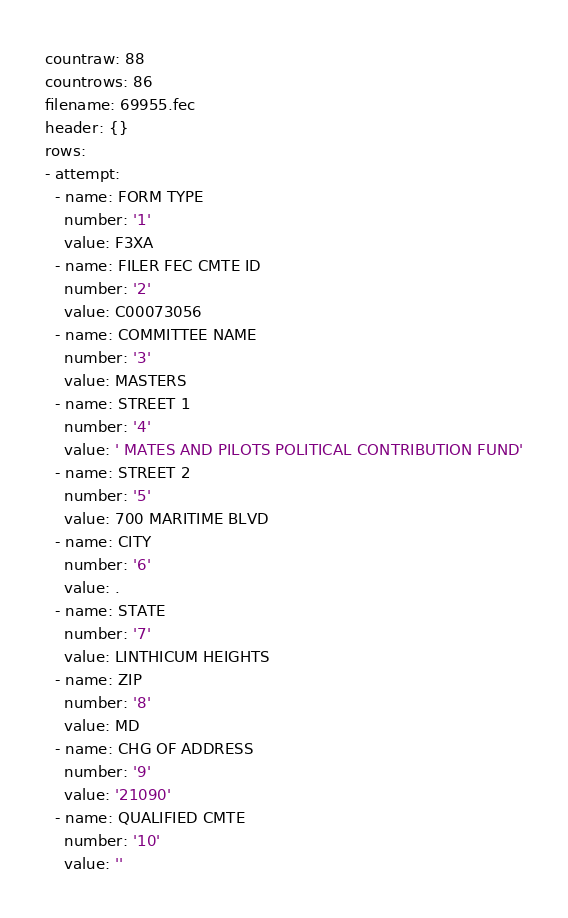Convert code to text. <code><loc_0><loc_0><loc_500><loc_500><_YAML_>countraw: 88
countrows: 86
filename: 69955.fec
header: {}
rows:
- attempt:
  - name: FORM TYPE
    number: '1'
    value: F3XA
  - name: FILER FEC CMTE ID
    number: '2'
    value: C00073056
  - name: COMMITTEE NAME
    number: '3'
    value: MASTERS
  - name: STREET 1
    number: '4'
    value: ' MATES AND PILOTS POLITICAL CONTRIBUTION FUND'
  - name: STREET 2
    number: '5'
    value: 700 MARITIME BLVD
  - name: CITY
    number: '6'
    value: .
  - name: STATE
    number: '7'
    value: LINTHICUM HEIGHTS
  - name: ZIP
    number: '8'
    value: MD
  - name: CHG OF ADDRESS
    number: '9'
    value: '21090'
  - name: QUALIFIED CMTE
    number: '10'
    value: ''</code> 